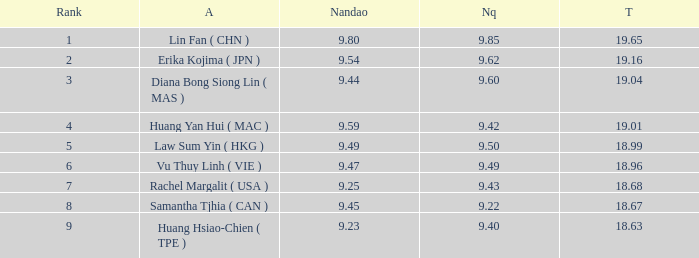Which Nanquan has a Nandao larger than 9.49, and a Rank of 4? 9.42. 